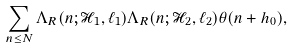Convert formula to latex. <formula><loc_0><loc_0><loc_500><loc_500>\sum _ { n \leq N } \Lambda _ { R } ( n ; \mathcal { H } _ { 1 } , \ell _ { 1 } ) \Lambda _ { R } ( n ; \mathcal { H } _ { 2 } , \ell _ { 2 } ) \theta ( n + h _ { 0 } ) ,</formula> 